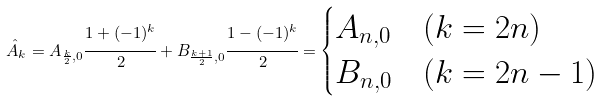Convert formula to latex. <formula><loc_0><loc_0><loc_500><loc_500>\hat { A } _ { k } = A _ { \frac { k } { 2 } , 0 } \cfrac { 1 + ( - 1 ) ^ { k } } { 2 } + B _ { \frac { k + 1 } { 2 } , 0 } \cfrac { 1 - ( - 1 ) ^ { k } } { 2 } = \begin{cases} A _ { n , 0 } & ( k = 2 n ) \\ B _ { n , 0 } & ( k = 2 n - 1 ) \end{cases}</formula> 